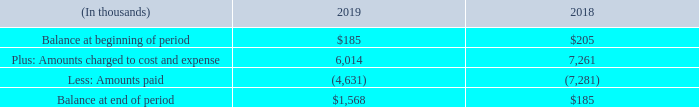Note 18 – Restructuring
During the second half of 2019, the Company implemented a restructuring plan to realign its expense structure with the reduction in revenue experienced in recent years and overall Company objectives. Management assessed the efficiency of our operations and consolidated locations and personnel, among other things, where possible. As part of this restructuring plan, the Company announced plans to reduce its overall operating expenses, both in the U.S and internationally.
In February 2019, the Company announced the restructuring of certain of our workforce predominantly in Germany, which included the closure of our office location in Munich, Germany accompanied by relocation or severance benefits for the affected employees. We also offered voluntary early retirement to certain other employees, which was announced in March 2019.
In January 2018, the Company announced an early retirement incentive program for employees that met certain defined requirements. The cumulative amount incurred during the year ended December 31, 2018 related to this restructuring program was $7.3 million. We did not incur any additional expenses related to this restructuring program during the year ended December 31, 2019.
A reconciliation of the beginning and ending restructuring liability, which is included in accrued wages and benefits in the Consolidated Balance Sheets as of December 31, 2019 and 2018, is as follows:
Why did the company implement a restructuring plan in 2019? To realign its expense structure with the reduction in revenue experienced in recent years and overall company objectives. What was the balance at the beginning of period in 2019?
Answer scale should be: thousand. $185. What was the balance at the end of period in 2019?
Answer scale should be: thousand. $1,568. What was the change in the balance at the beginning of the period and end of the period in 2019?
Answer scale should be: thousand. $1,568-$185
Answer: 1383. What was the change in Amounts charged to cost and expense between 2018 and 2019?
Answer scale should be: thousand. 6,014-7,261
Answer: -1247. Which year had a larger change in  Balance at beginning of period to  Balance at end of period? 2019:($1,568-$185=$1,383) 2018:($185- $205=-$20). 1,383>|-20|
Answer: 2019. 